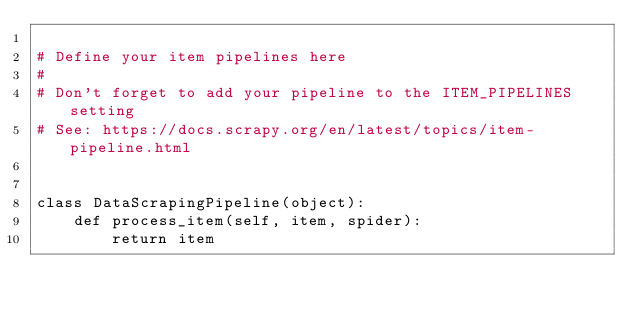<code> <loc_0><loc_0><loc_500><loc_500><_Python_>
# Define your item pipelines here
#
# Don't forget to add your pipeline to the ITEM_PIPELINES setting
# See: https://docs.scrapy.org/en/latest/topics/item-pipeline.html


class DataScrapingPipeline(object):
    def process_item(self, item, spider):
        return item
</code> 